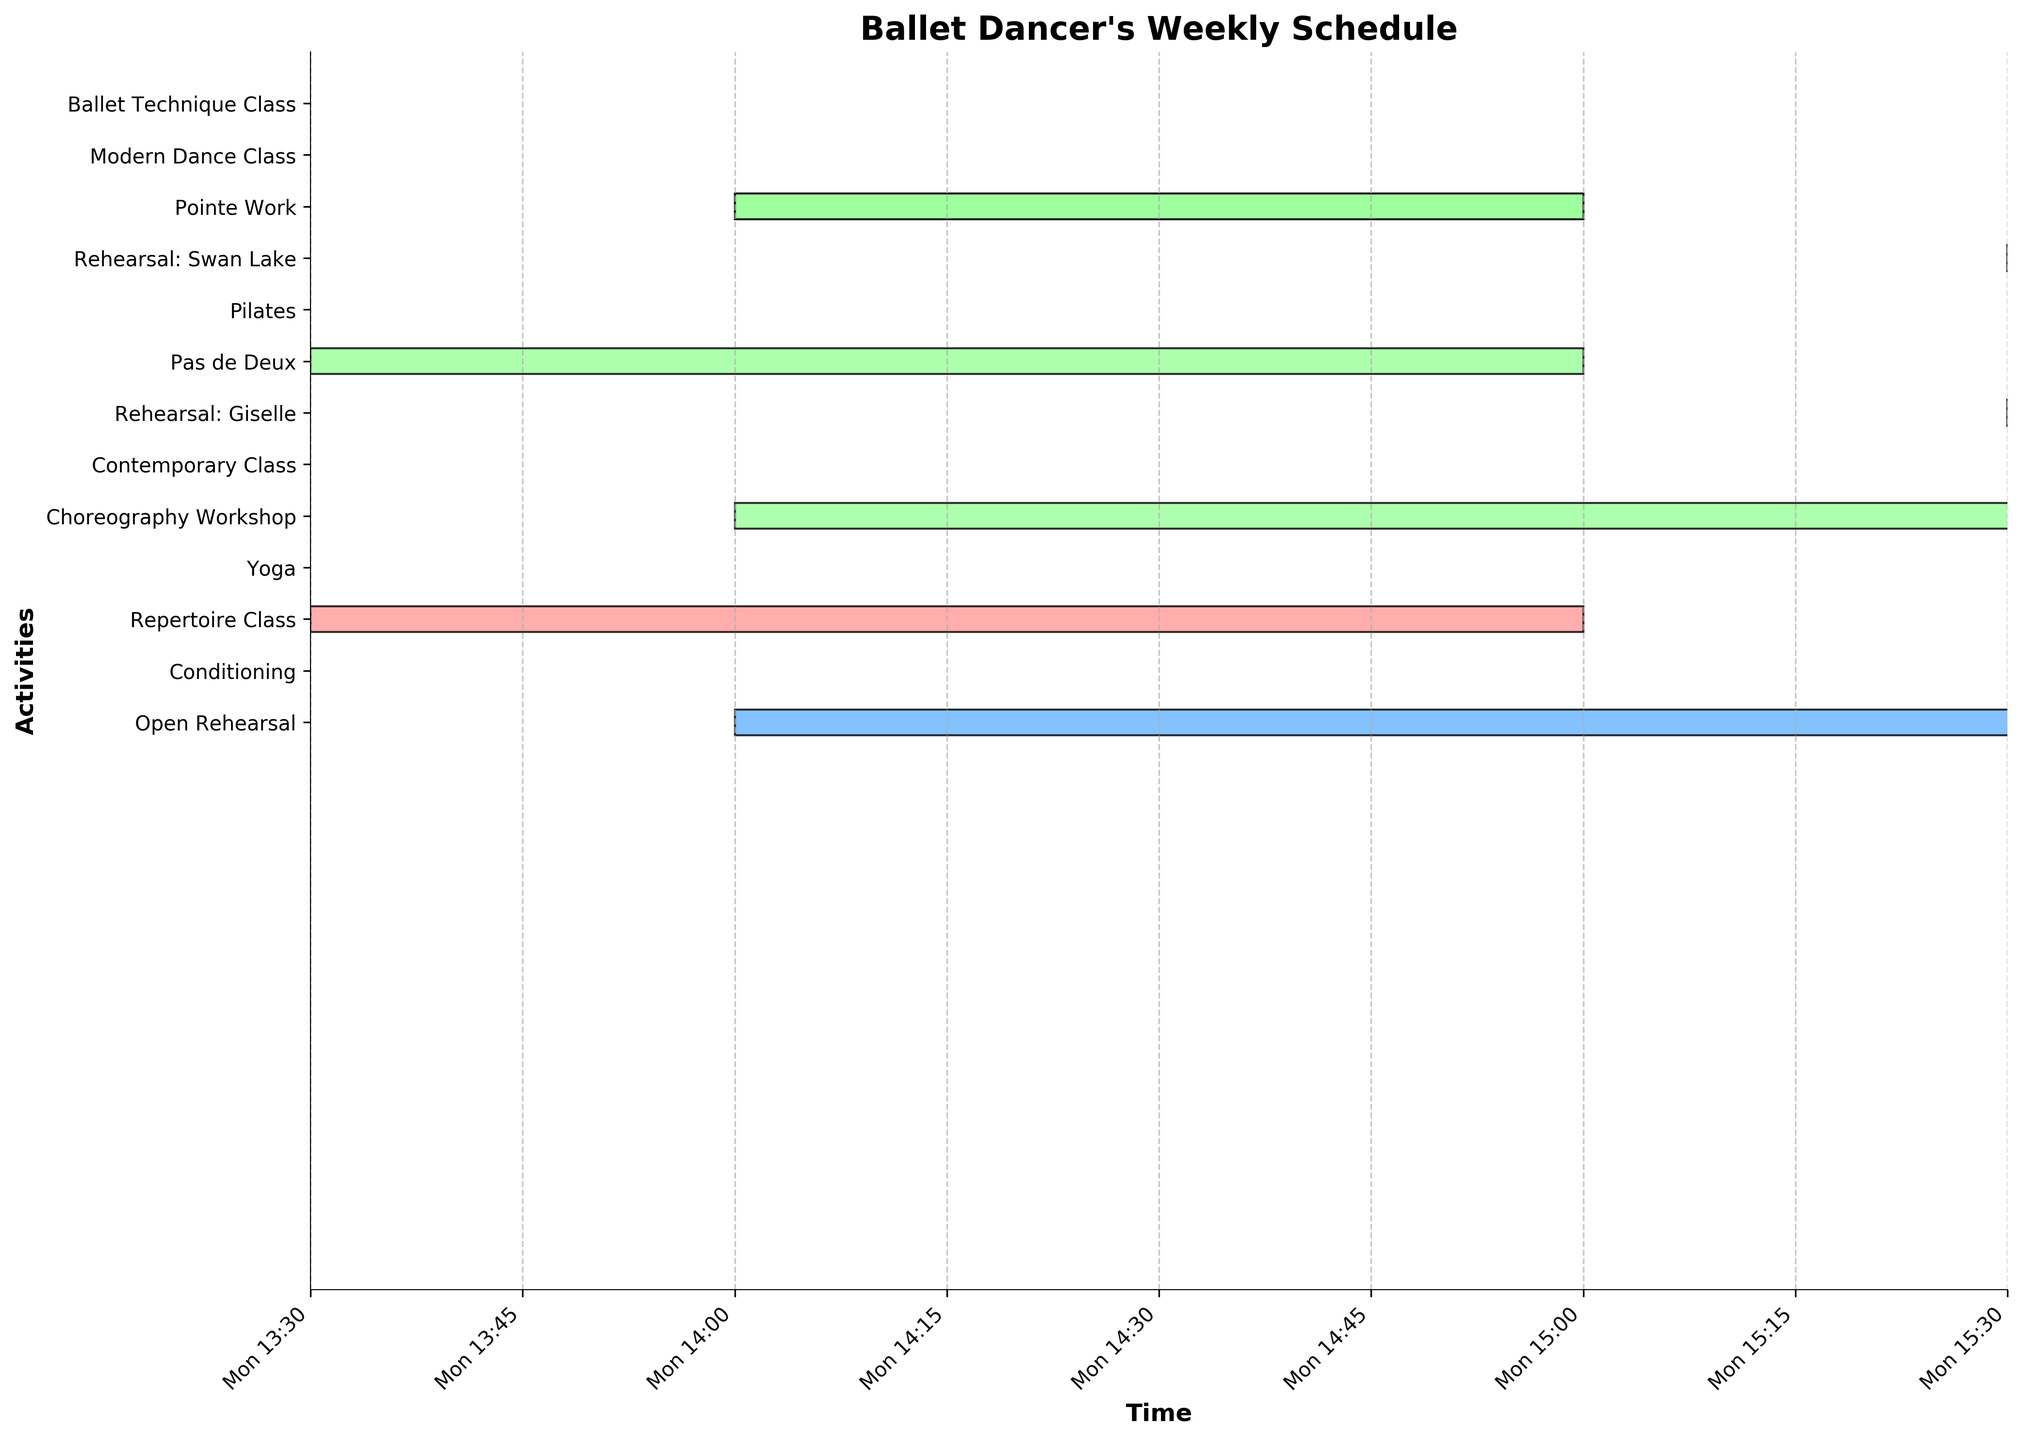How many classes does the dancer have each week? Look for the tasks categorized as "Class". Count each occasion where a class, such as "Ballet Technique Class", "Modern Dance Class", etc., is mentioned.
Answer: 14 Between "Choreography Workshop" and "Conditioning," which one takes place later in the week? Compare the start days and times of "Choreography Workshop" and "Conditioning". The "Choreography Workshop" starts on Wednesday, while "Conditioning" starts on Saturday.
Answer: Conditioning What's the total duration spent on rehearsals throughout the week? Sum the durations of all rehearsal tasks. Each day has specific rehearsal durations: Monday (3 hours), Tuesday (3 hours), Wednesday (3 hours), Thursday (3 hours), Friday (3 hours), Saturday (3 hours). Total duration = 5 * 3 hours + 1 * 3 hours = 18 hours.
Answer: 18 hours How many different types of rehearsals does the dancer participate in? Identify each unique rehearsal type. The list includes "Rehearsal: Swan Lake," "Rehearsal: Giselle," and "Open Rehearsal."
Answer: 3 Which day has the highest number of activities scheduled? Count the number of activities for each day:
  - Monday: 4 activities
  - Tuesday: 4 activities
  - Wednesday: 4 activities
  - Thursday: 4 activities
  - Friday: 4 activities
  - Saturday: 3 activities
 Monday, Tuesday, Wednesday, Thursday, and Friday all have the highest number with 4 activities each.
Answer: Monday, Tuesday, Wednesday, Thursday, Friday How often does "Ballet Technique Class" appear on the schedule? Find and count each instance of "Ballet Technique Class". The term appears once on Monday, once on Tuesday, once on Wednesday, once on Thursday, once on Friday, and once on Saturday.
Answer: 6 Which class starts first in the weekly schedule and what time does it begin? Identify the earliest starting time of all the classes. "Ballet Technique Class" on Monday starts at 09:00, which is the earliest.
Answer: Ballet Technique Class at 09:00 on Monday On which day is the "Open Rehearsal" scheduled, and for how long does it last? Find "Open Rehearsal" in the schedule and note its day and duration. It is scheduled on Saturday from 14:00 to 17:00, lasting 3 hours.
Answer: Saturday, 3 hours 